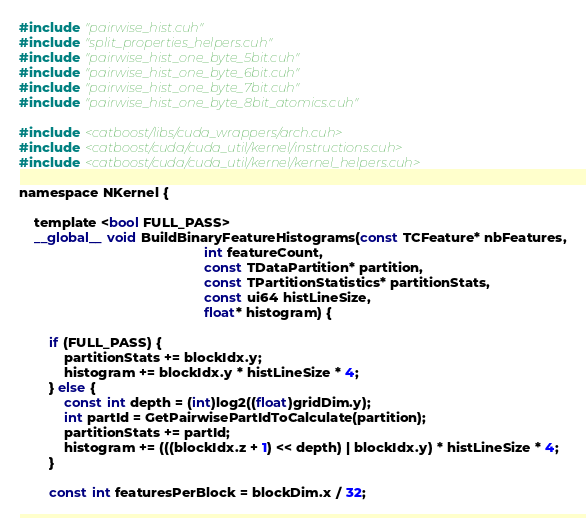Convert code to text. <code><loc_0><loc_0><loc_500><loc_500><_Cuda_>#include "pairwise_hist.cuh"
#include "split_properties_helpers.cuh"
#include "pairwise_hist_one_byte_5bit.cuh"
#include "pairwise_hist_one_byte_6bit.cuh"
#include "pairwise_hist_one_byte_7bit.cuh"
#include "pairwise_hist_one_byte_8bit_atomics.cuh"

#include <catboost/libs/cuda_wrappers/arch.cuh>
#include <catboost/cuda/cuda_util/kernel/instructions.cuh>
#include <catboost/cuda/cuda_util/kernel/kernel_helpers.cuh>

namespace NKernel {

    template <bool FULL_PASS>
    __global__ void BuildBinaryFeatureHistograms(const TCFeature* nbFeatures,
                                                 int featureCount,
                                                 const TDataPartition* partition,
                                                 const TPartitionStatistics* partitionStats,
                                                 const ui64 histLineSize,
                                                 float* histogram) {

        if (FULL_PASS) {
            partitionStats += blockIdx.y;
            histogram += blockIdx.y * histLineSize * 4;
        } else {
            const int depth = (int)log2((float)gridDim.y);
            int partId = GetPairwisePartIdToCalculate(partition);
            partitionStats += partId;
            histogram += (((blockIdx.z + 1) << depth) | blockIdx.y) * histLineSize * 4;
        }

        const int featuresPerBlock = blockDim.x / 32;</code> 